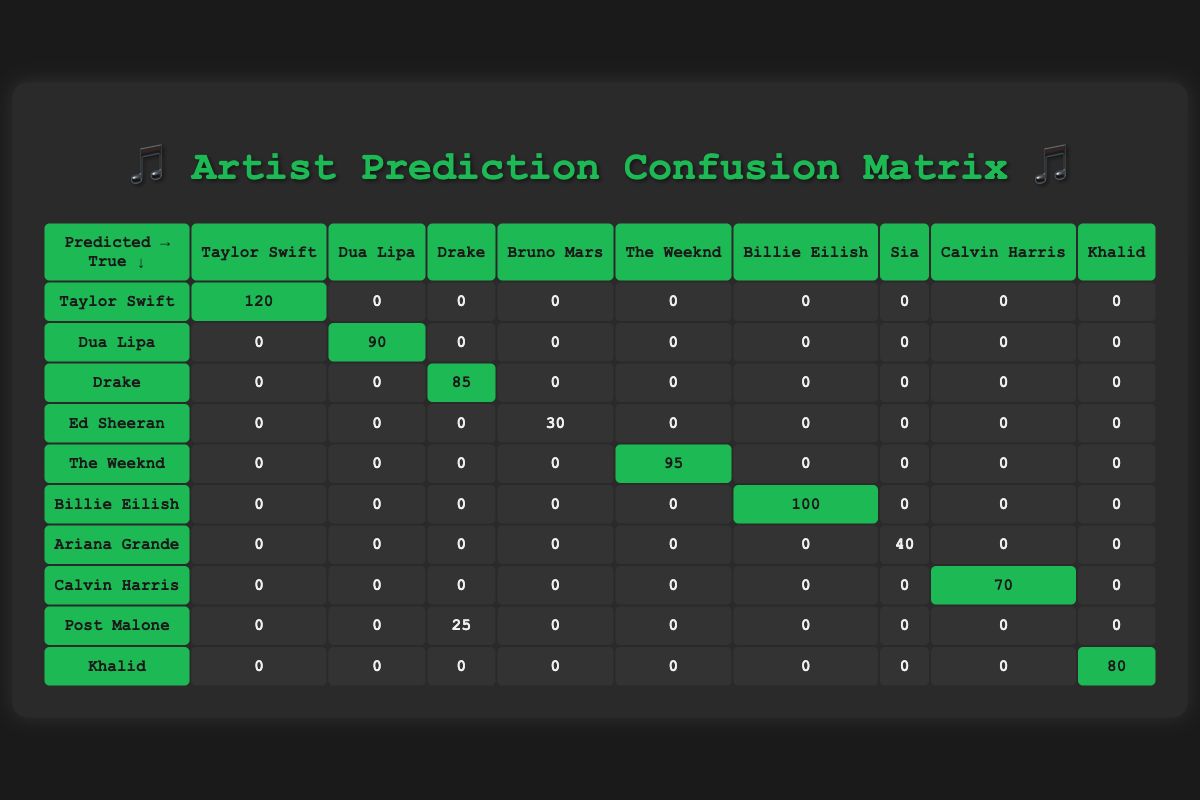What is the count of correct predictions for Taylor Swift? According to the table, the count for the correct prediction of Taylor Swift (where the true artist and predicted artist match) is found in the row corresponding to Taylor Swift, under Taylor Swift. That value is 120.
Answer: 120 What is the total count of predicted listeners for Drake? To find the total count of predicted listeners for Drake, we look at all rows where Drake is listed as the predicted artist. In this case, it's only in the row for Drake itself, which shows a count of 85. Additionally, Post Malone has predicted 25 for Drake, so we can add these two counts together: 85 + 25 = 110.
Answer: 110 Is there a higher count of predictions for Billie Eilish than for Ariana Grande? Billie Eilish has a count of 100 under the correct predictions, while Ariana Grande has a count of 40. Comparing these two counts, it is clear that 100 is greater than 40.
Answer: Yes What is the total number of correct predictions across all artists? To find the total number of correct predictions, we add the values on the diagonal of the table, where the true artist matches the predicted artist. This includes: 120 (Taylor Swift) + 90 (Dua Lipa) + 85 (Drake) + 95 (The Weeknd) + 100 (Billie Eilish) + 70 (Calvin Harris) + 80 (Khalid), which equals 120 + 90 + 85 + 95 + 100 + 70 + 80 = 740.
Answer: 740 How many artists received zero predictions from listeners? Analyzing each row, we see that there are several cells (which represent predictions) that have a value of zero across different artists. Specifically for Ariana Grande, Ed Sheeran, and the others listed except for those mentioned, we count these rows. The specific number of artists who received zero predictions is seven.
Answer: 7 